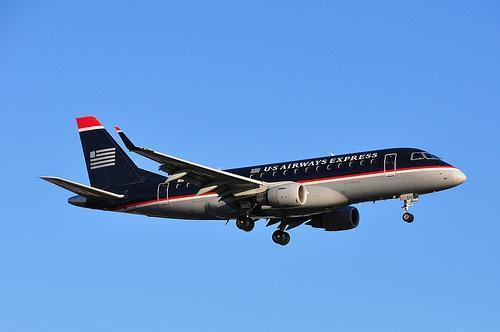How many wings are visible on the plane?
Give a very brief answer. 2. 